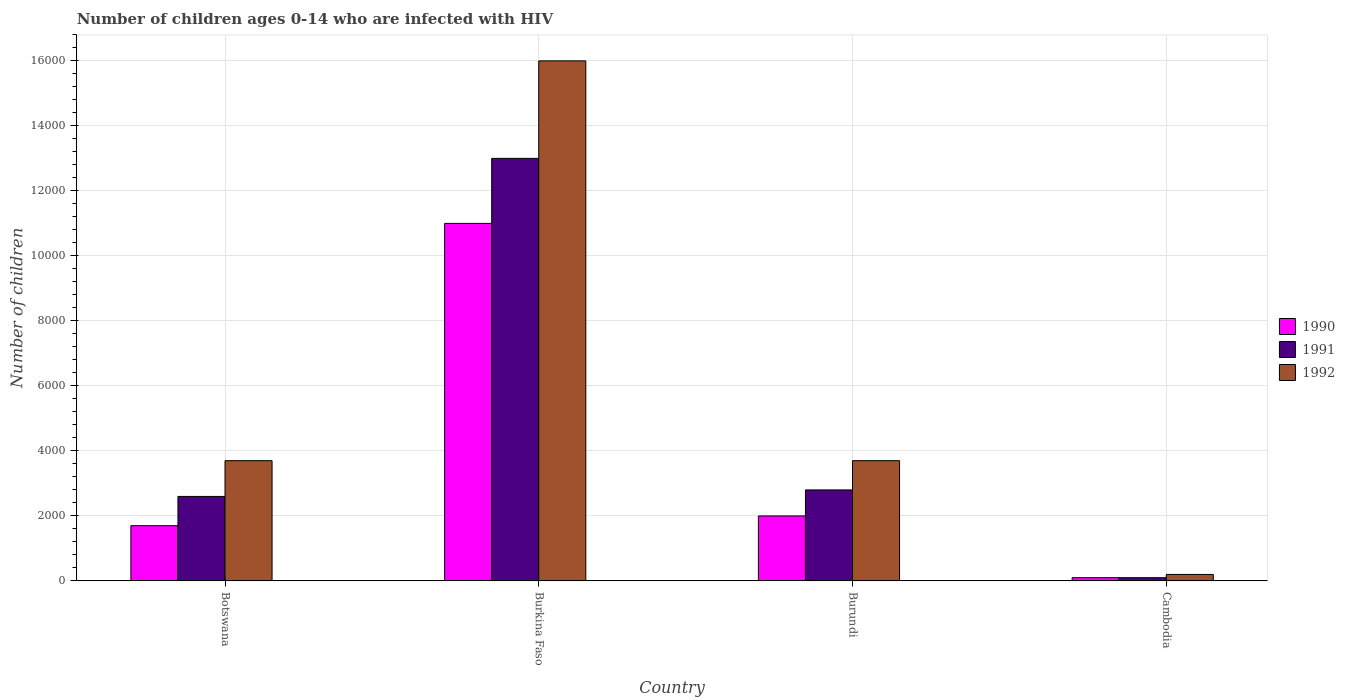How many different coloured bars are there?
Make the answer very short. 3. Are the number of bars on each tick of the X-axis equal?
Your answer should be very brief. Yes. How many bars are there on the 3rd tick from the left?
Provide a succinct answer. 3. How many bars are there on the 4th tick from the right?
Provide a succinct answer. 3. What is the label of the 3rd group of bars from the left?
Provide a succinct answer. Burundi. What is the number of HIV infected children in 1992 in Botswana?
Give a very brief answer. 3700. Across all countries, what is the maximum number of HIV infected children in 1992?
Give a very brief answer. 1.60e+04. Across all countries, what is the minimum number of HIV infected children in 1991?
Your answer should be compact. 100. In which country was the number of HIV infected children in 1992 maximum?
Your response must be concise. Burkina Faso. In which country was the number of HIV infected children in 1991 minimum?
Offer a terse response. Cambodia. What is the total number of HIV infected children in 1991 in the graph?
Ensure brevity in your answer.  1.85e+04. What is the difference between the number of HIV infected children in 1990 in Burkina Faso and that in Burundi?
Provide a short and direct response. 9000. What is the difference between the number of HIV infected children in 1991 in Botswana and the number of HIV infected children in 1992 in Cambodia?
Your answer should be compact. 2400. What is the average number of HIV infected children in 1990 per country?
Give a very brief answer. 3700. What is the difference between the number of HIV infected children of/in 1991 and number of HIV infected children of/in 1992 in Burkina Faso?
Keep it short and to the point. -3000. Is the number of HIV infected children in 1990 in Botswana less than that in Burundi?
Make the answer very short. Yes. Is the difference between the number of HIV infected children in 1991 in Burundi and Cambodia greater than the difference between the number of HIV infected children in 1992 in Burundi and Cambodia?
Offer a terse response. No. What is the difference between the highest and the second highest number of HIV infected children in 1992?
Your answer should be compact. 1.23e+04. What is the difference between the highest and the lowest number of HIV infected children in 1991?
Your answer should be compact. 1.29e+04. In how many countries, is the number of HIV infected children in 1991 greater than the average number of HIV infected children in 1991 taken over all countries?
Make the answer very short. 1. How many bars are there?
Provide a succinct answer. 12. What is the difference between two consecutive major ticks on the Y-axis?
Your answer should be very brief. 2000. Does the graph contain grids?
Ensure brevity in your answer.  Yes. Where does the legend appear in the graph?
Provide a short and direct response. Center right. What is the title of the graph?
Provide a succinct answer. Number of children ages 0-14 who are infected with HIV. What is the label or title of the Y-axis?
Provide a succinct answer. Number of children. What is the Number of children in 1990 in Botswana?
Provide a short and direct response. 1700. What is the Number of children of 1991 in Botswana?
Make the answer very short. 2600. What is the Number of children of 1992 in Botswana?
Provide a succinct answer. 3700. What is the Number of children of 1990 in Burkina Faso?
Make the answer very short. 1.10e+04. What is the Number of children in 1991 in Burkina Faso?
Make the answer very short. 1.30e+04. What is the Number of children in 1992 in Burkina Faso?
Your answer should be compact. 1.60e+04. What is the Number of children of 1990 in Burundi?
Your answer should be compact. 2000. What is the Number of children in 1991 in Burundi?
Keep it short and to the point. 2800. What is the Number of children in 1992 in Burundi?
Make the answer very short. 3700. What is the Number of children of 1990 in Cambodia?
Offer a very short reply. 100. What is the Number of children in 1992 in Cambodia?
Offer a very short reply. 200. Across all countries, what is the maximum Number of children of 1990?
Provide a succinct answer. 1.10e+04. Across all countries, what is the maximum Number of children in 1991?
Ensure brevity in your answer.  1.30e+04. Across all countries, what is the maximum Number of children of 1992?
Your answer should be very brief. 1.60e+04. What is the total Number of children of 1990 in the graph?
Ensure brevity in your answer.  1.48e+04. What is the total Number of children of 1991 in the graph?
Keep it short and to the point. 1.85e+04. What is the total Number of children of 1992 in the graph?
Your answer should be compact. 2.36e+04. What is the difference between the Number of children of 1990 in Botswana and that in Burkina Faso?
Give a very brief answer. -9300. What is the difference between the Number of children in 1991 in Botswana and that in Burkina Faso?
Provide a short and direct response. -1.04e+04. What is the difference between the Number of children in 1992 in Botswana and that in Burkina Faso?
Offer a terse response. -1.23e+04. What is the difference between the Number of children in 1990 in Botswana and that in Burundi?
Give a very brief answer. -300. What is the difference between the Number of children of 1991 in Botswana and that in Burundi?
Ensure brevity in your answer.  -200. What is the difference between the Number of children in 1990 in Botswana and that in Cambodia?
Your answer should be very brief. 1600. What is the difference between the Number of children in 1991 in Botswana and that in Cambodia?
Your answer should be very brief. 2500. What is the difference between the Number of children of 1992 in Botswana and that in Cambodia?
Keep it short and to the point. 3500. What is the difference between the Number of children in 1990 in Burkina Faso and that in Burundi?
Your answer should be very brief. 9000. What is the difference between the Number of children in 1991 in Burkina Faso and that in Burundi?
Your response must be concise. 1.02e+04. What is the difference between the Number of children of 1992 in Burkina Faso and that in Burundi?
Make the answer very short. 1.23e+04. What is the difference between the Number of children of 1990 in Burkina Faso and that in Cambodia?
Your answer should be compact. 1.09e+04. What is the difference between the Number of children of 1991 in Burkina Faso and that in Cambodia?
Provide a succinct answer. 1.29e+04. What is the difference between the Number of children of 1992 in Burkina Faso and that in Cambodia?
Ensure brevity in your answer.  1.58e+04. What is the difference between the Number of children of 1990 in Burundi and that in Cambodia?
Provide a succinct answer. 1900. What is the difference between the Number of children in 1991 in Burundi and that in Cambodia?
Offer a very short reply. 2700. What is the difference between the Number of children in 1992 in Burundi and that in Cambodia?
Give a very brief answer. 3500. What is the difference between the Number of children of 1990 in Botswana and the Number of children of 1991 in Burkina Faso?
Your answer should be very brief. -1.13e+04. What is the difference between the Number of children in 1990 in Botswana and the Number of children in 1992 in Burkina Faso?
Make the answer very short. -1.43e+04. What is the difference between the Number of children in 1991 in Botswana and the Number of children in 1992 in Burkina Faso?
Give a very brief answer. -1.34e+04. What is the difference between the Number of children of 1990 in Botswana and the Number of children of 1991 in Burundi?
Give a very brief answer. -1100. What is the difference between the Number of children in 1990 in Botswana and the Number of children in 1992 in Burundi?
Ensure brevity in your answer.  -2000. What is the difference between the Number of children in 1991 in Botswana and the Number of children in 1992 in Burundi?
Provide a short and direct response. -1100. What is the difference between the Number of children in 1990 in Botswana and the Number of children in 1991 in Cambodia?
Make the answer very short. 1600. What is the difference between the Number of children in 1990 in Botswana and the Number of children in 1992 in Cambodia?
Your answer should be compact. 1500. What is the difference between the Number of children of 1991 in Botswana and the Number of children of 1992 in Cambodia?
Ensure brevity in your answer.  2400. What is the difference between the Number of children of 1990 in Burkina Faso and the Number of children of 1991 in Burundi?
Provide a short and direct response. 8200. What is the difference between the Number of children of 1990 in Burkina Faso and the Number of children of 1992 in Burundi?
Keep it short and to the point. 7300. What is the difference between the Number of children in 1991 in Burkina Faso and the Number of children in 1992 in Burundi?
Your answer should be compact. 9300. What is the difference between the Number of children of 1990 in Burkina Faso and the Number of children of 1991 in Cambodia?
Offer a very short reply. 1.09e+04. What is the difference between the Number of children of 1990 in Burkina Faso and the Number of children of 1992 in Cambodia?
Your answer should be very brief. 1.08e+04. What is the difference between the Number of children of 1991 in Burkina Faso and the Number of children of 1992 in Cambodia?
Your answer should be very brief. 1.28e+04. What is the difference between the Number of children in 1990 in Burundi and the Number of children in 1991 in Cambodia?
Provide a succinct answer. 1900. What is the difference between the Number of children of 1990 in Burundi and the Number of children of 1992 in Cambodia?
Your answer should be very brief. 1800. What is the difference between the Number of children of 1991 in Burundi and the Number of children of 1992 in Cambodia?
Provide a short and direct response. 2600. What is the average Number of children in 1990 per country?
Your answer should be compact. 3700. What is the average Number of children of 1991 per country?
Your answer should be compact. 4625. What is the average Number of children in 1992 per country?
Keep it short and to the point. 5900. What is the difference between the Number of children in 1990 and Number of children in 1991 in Botswana?
Offer a terse response. -900. What is the difference between the Number of children in 1990 and Number of children in 1992 in Botswana?
Provide a succinct answer. -2000. What is the difference between the Number of children of 1991 and Number of children of 1992 in Botswana?
Your answer should be very brief. -1100. What is the difference between the Number of children of 1990 and Number of children of 1991 in Burkina Faso?
Offer a terse response. -2000. What is the difference between the Number of children of 1990 and Number of children of 1992 in Burkina Faso?
Offer a terse response. -5000. What is the difference between the Number of children in 1991 and Number of children in 1992 in Burkina Faso?
Make the answer very short. -3000. What is the difference between the Number of children in 1990 and Number of children in 1991 in Burundi?
Ensure brevity in your answer.  -800. What is the difference between the Number of children in 1990 and Number of children in 1992 in Burundi?
Give a very brief answer. -1700. What is the difference between the Number of children of 1991 and Number of children of 1992 in Burundi?
Your response must be concise. -900. What is the difference between the Number of children of 1990 and Number of children of 1992 in Cambodia?
Offer a terse response. -100. What is the difference between the Number of children of 1991 and Number of children of 1992 in Cambodia?
Provide a succinct answer. -100. What is the ratio of the Number of children in 1990 in Botswana to that in Burkina Faso?
Offer a very short reply. 0.15. What is the ratio of the Number of children in 1992 in Botswana to that in Burkina Faso?
Provide a short and direct response. 0.23. What is the ratio of the Number of children in 1990 in Botswana to that in Cambodia?
Your response must be concise. 17. What is the ratio of the Number of children of 1990 in Burkina Faso to that in Burundi?
Offer a terse response. 5.5. What is the ratio of the Number of children of 1991 in Burkina Faso to that in Burundi?
Your answer should be compact. 4.64. What is the ratio of the Number of children of 1992 in Burkina Faso to that in Burundi?
Offer a very short reply. 4.32. What is the ratio of the Number of children in 1990 in Burkina Faso to that in Cambodia?
Provide a short and direct response. 110. What is the ratio of the Number of children of 1991 in Burkina Faso to that in Cambodia?
Offer a very short reply. 130. What is the ratio of the Number of children in 1992 in Burundi to that in Cambodia?
Your response must be concise. 18.5. What is the difference between the highest and the second highest Number of children in 1990?
Make the answer very short. 9000. What is the difference between the highest and the second highest Number of children of 1991?
Offer a terse response. 1.02e+04. What is the difference between the highest and the second highest Number of children in 1992?
Provide a succinct answer. 1.23e+04. What is the difference between the highest and the lowest Number of children of 1990?
Keep it short and to the point. 1.09e+04. What is the difference between the highest and the lowest Number of children in 1991?
Offer a terse response. 1.29e+04. What is the difference between the highest and the lowest Number of children of 1992?
Provide a succinct answer. 1.58e+04. 